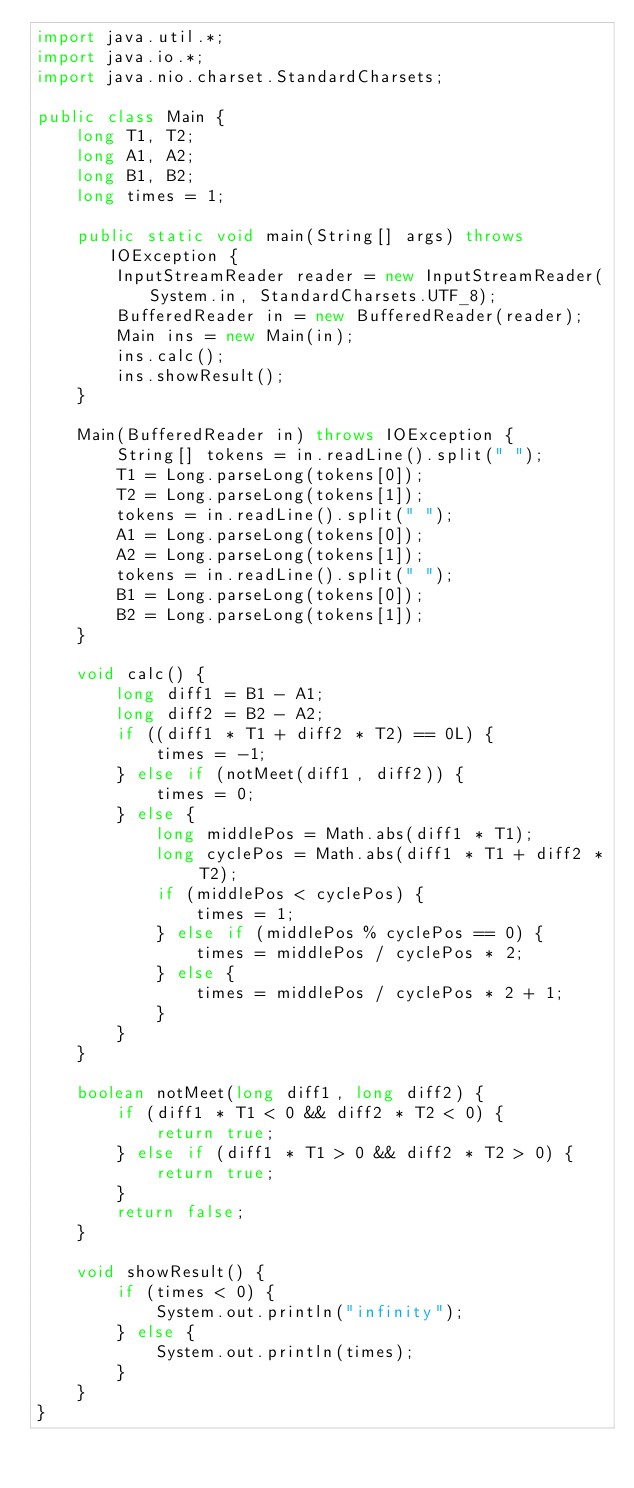Convert code to text. <code><loc_0><loc_0><loc_500><loc_500><_Java_>import java.util.*;
import java.io.*;
import java.nio.charset.StandardCharsets;

public class Main {
	long T1, T2;
	long A1, A2;
	long B1, B2;
	long times = 1;

	public static void main(String[] args) throws IOException {
		InputStreamReader reader = new InputStreamReader(System.in, StandardCharsets.UTF_8);
		BufferedReader in = new BufferedReader(reader);
		Main ins = new Main(in);
		ins.calc();
		ins.showResult();
	}

	Main(BufferedReader in) throws IOException {
		String[] tokens = in.readLine().split(" ");
		T1 = Long.parseLong(tokens[0]);
		T2 = Long.parseLong(tokens[1]);
		tokens = in.readLine().split(" ");
		A1 = Long.parseLong(tokens[0]);
		A2 = Long.parseLong(tokens[1]);
		tokens = in.readLine().split(" ");
		B1 = Long.parseLong(tokens[0]);
		B2 = Long.parseLong(tokens[1]);
	}

	void calc() {
		long diff1 = B1 - A1;
		long diff2 = B2 - A2;
		if ((diff1 * T1 + diff2 * T2) == 0L) {
			times = -1;
		} else if (notMeet(diff1, diff2)) {
			times = 0;
		} else {
			long middlePos = Math.abs(diff1 * T1);
			long cyclePos = Math.abs(diff1 * T1 + diff2 * T2);
			if (middlePos < cyclePos) {
				times = 1;
			} else if (middlePos % cyclePos == 0) {
				times = middlePos / cyclePos * 2;
			} else {
				times = middlePos / cyclePos * 2 + 1;
			}
		}
	}

	boolean notMeet(long diff1, long diff2) {
		if (diff1 * T1 < 0 && diff2 * T2 < 0) {
			return true;
		} else if (diff1 * T1 > 0 && diff2 * T2 > 0) {
			return true;
		}
		return false;
	}

	void showResult() {
		if (times < 0) {
			System.out.println("infinity");
		} else {
			System.out.println(times);
		}
	}
}</code> 